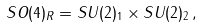Convert formula to latex. <formula><loc_0><loc_0><loc_500><loc_500>S O ( 4 ) _ { R } = S U ( 2 ) _ { 1 } \times S U ( 2 ) _ { 2 } \, ,</formula> 